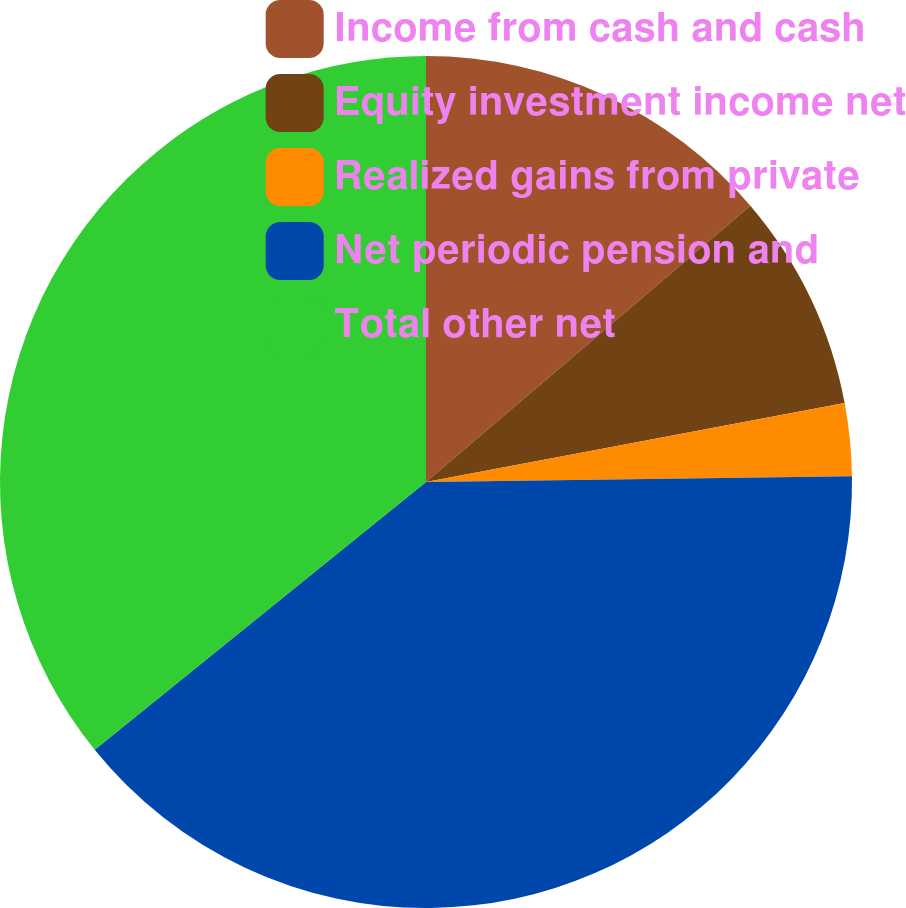Convert chart. <chart><loc_0><loc_0><loc_500><loc_500><pie_chart><fcel>Income from cash and cash<fcel>Equity investment income net<fcel>Realized gains from private<fcel>Net periodic pension and<fcel>Total other net<nl><fcel>13.77%<fcel>8.26%<fcel>2.75%<fcel>39.39%<fcel>35.81%<nl></chart> 